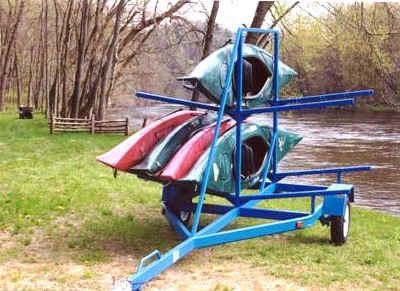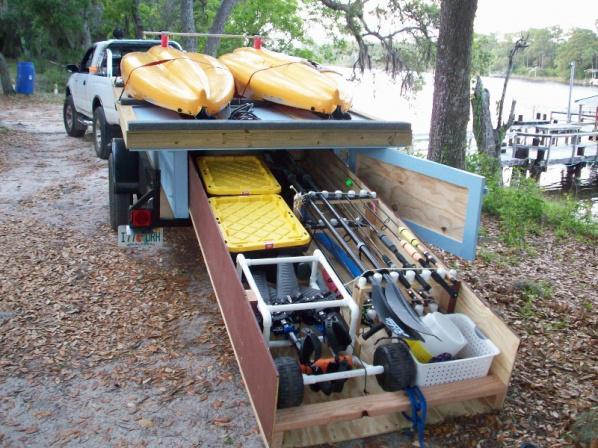The first image is the image on the left, the second image is the image on the right. Analyze the images presented: Is the assertion "There are at least five canoes in the image on the left." valid? Answer yes or no. Yes. The first image is the image on the left, the second image is the image on the right. For the images displayed, is the sentence "An image shows two orange boats atop a trailer." factually correct? Answer yes or no. Yes. 